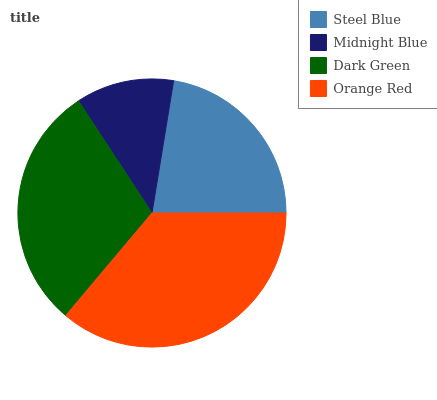Is Midnight Blue the minimum?
Answer yes or no. Yes. Is Orange Red the maximum?
Answer yes or no. Yes. Is Dark Green the minimum?
Answer yes or no. No. Is Dark Green the maximum?
Answer yes or no. No. Is Dark Green greater than Midnight Blue?
Answer yes or no. Yes. Is Midnight Blue less than Dark Green?
Answer yes or no. Yes. Is Midnight Blue greater than Dark Green?
Answer yes or no. No. Is Dark Green less than Midnight Blue?
Answer yes or no. No. Is Dark Green the high median?
Answer yes or no. Yes. Is Steel Blue the low median?
Answer yes or no. Yes. Is Orange Red the high median?
Answer yes or no. No. Is Orange Red the low median?
Answer yes or no. No. 